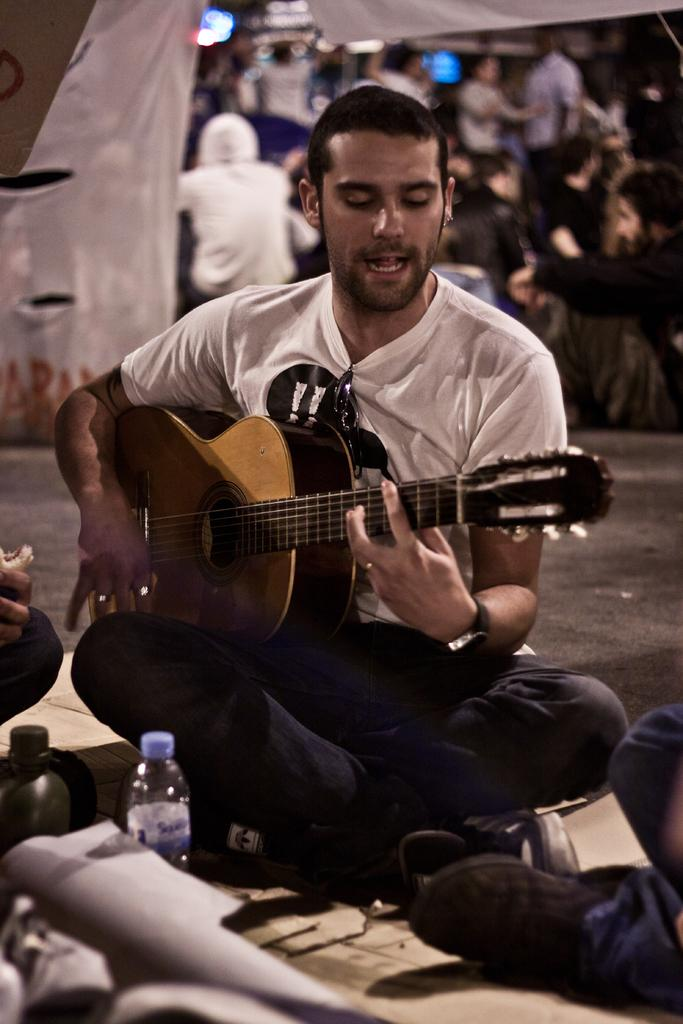What is the man in the image doing? The man is sitting on the road and playing a guitar. What object is in front of the man? There is a bottle in front of the man. Who is in front of the man? There is another person in front of the man. What can be observed in the background of the image? There are many people in the background. What type of glove is the man wearing while playing the guitar? The man is not wearing a glove in the image; he is playing the guitar with his bare hands. 